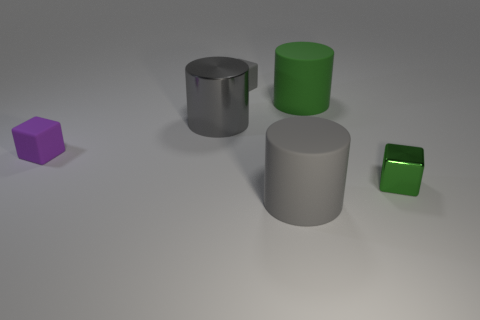How many gray cylinders must be subtracted to get 1 gray cylinders? 1 Add 3 small green things. How many objects exist? 9 Subtract all small purple cubes. How many cubes are left? 2 Subtract 2 cylinders. How many cylinders are left? 1 Add 3 rubber cubes. How many rubber cubes exist? 5 Subtract all purple blocks. How many blocks are left? 2 Subtract 0 brown balls. How many objects are left? 6 Subtract all brown blocks. Subtract all yellow cylinders. How many blocks are left? 3 Subtract all purple cubes. How many green cylinders are left? 1 Subtract all rubber objects. Subtract all tiny green blocks. How many objects are left? 1 